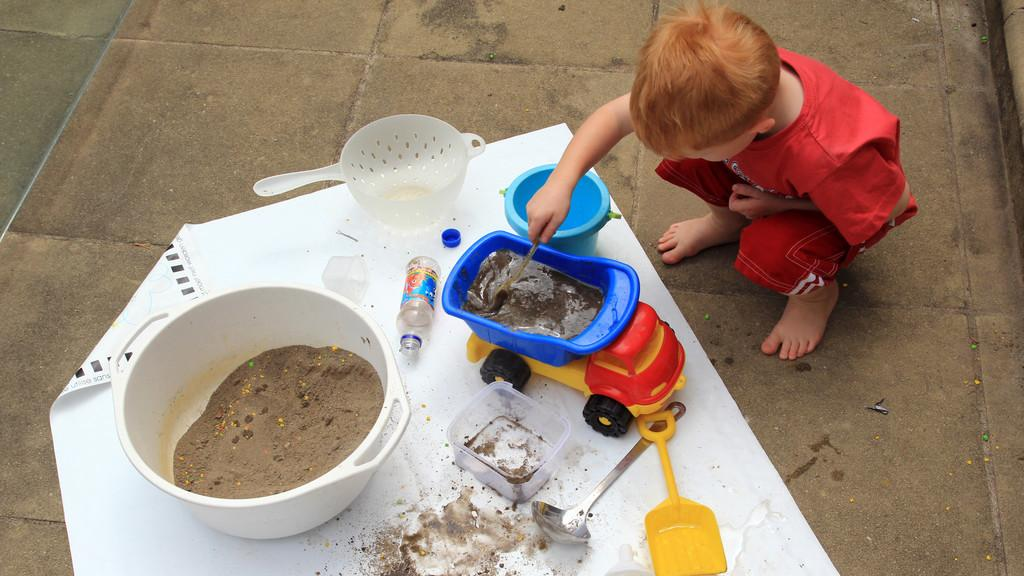What is present in the image along with the person? There is a bowl, a bottle, a toy, a spoon, and a sheet at the bottom of the image. Can you describe the objects at the bottom of the image? There is a bowl, a bottle, a toy, a spoon, and a sheet at the bottom of the image. What might the person in the image be using the spoon for? The spoon could be used for eating or scooping something from the bowl. How many frogs are sitting on the eggnog in the image? There are no frogs or eggnog present in the image. What advice might the person's aunt give them in the image? There is no reference to an aunt in the image, so it's not possible to determine what advice she might give. 